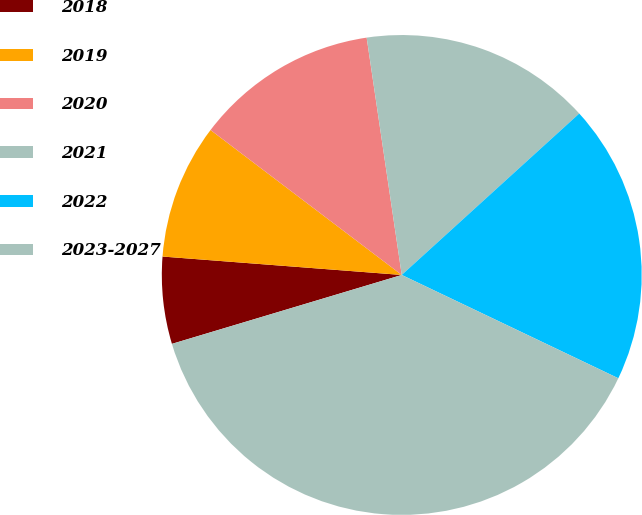Convert chart to OTSL. <chart><loc_0><loc_0><loc_500><loc_500><pie_chart><fcel>2018<fcel>2019<fcel>2020<fcel>2021<fcel>2022<fcel>2023-2027<nl><fcel>5.86%<fcel>9.1%<fcel>12.34%<fcel>15.59%<fcel>18.83%<fcel>38.28%<nl></chart> 